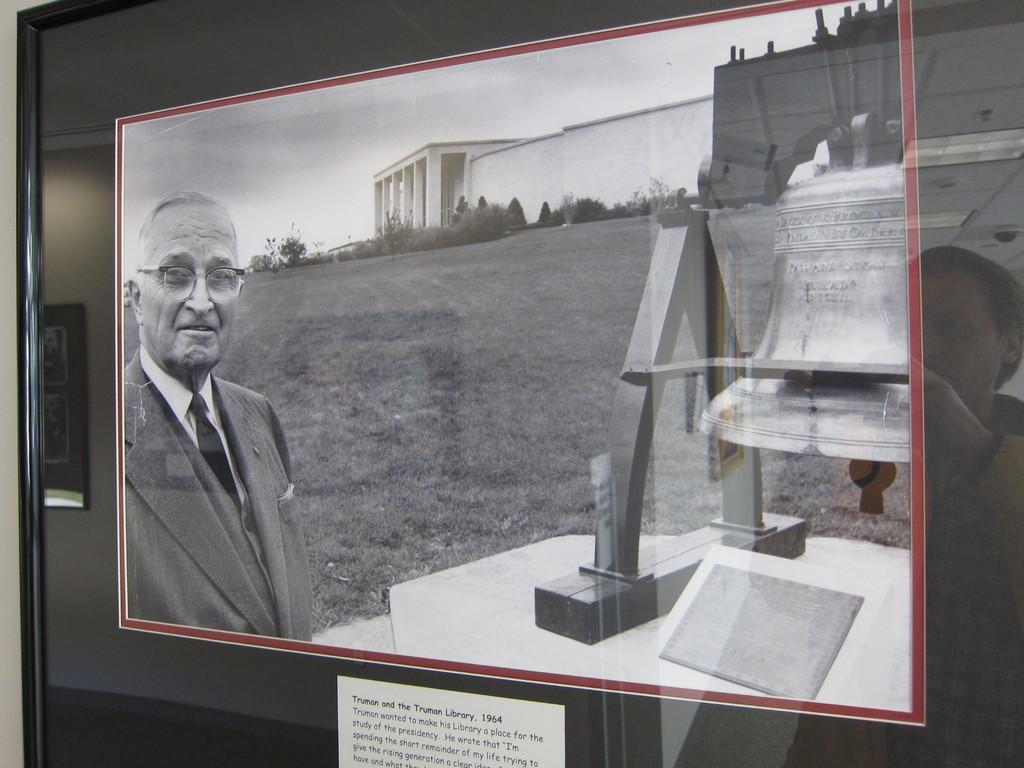Can you describe this image briefly? In this picture we can see few posts on the glass, behind the glass we can see a person. 